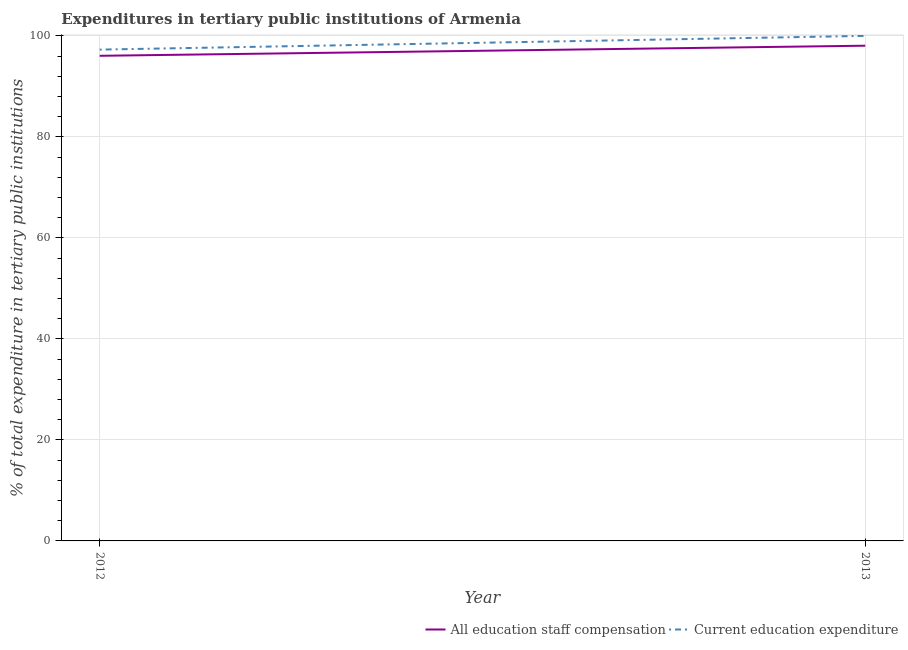What is the expenditure in staff compensation in 2013?
Keep it short and to the point. 98.05. Across all years, what is the maximum expenditure in staff compensation?
Your answer should be compact. 98.05. Across all years, what is the minimum expenditure in education?
Provide a succinct answer. 97.28. What is the total expenditure in staff compensation in the graph?
Offer a terse response. 194.1. What is the difference between the expenditure in education in 2012 and that in 2013?
Offer a very short reply. -2.72. What is the difference between the expenditure in education in 2013 and the expenditure in staff compensation in 2012?
Offer a very short reply. 3.95. What is the average expenditure in education per year?
Provide a succinct answer. 98.64. In the year 2012, what is the difference between the expenditure in education and expenditure in staff compensation?
Provide a short and direct response. 1.23. In how many years, is the expenditure in education greater than 12 %?
Give a very brief answer. 2. What is the ratio of the expenditure in staff compensation in 2012 to that in 2013?
Offer a very short reply. 0.98. In how many years, is the expenditure in staff compensation greater than the average expenditure in staff compensation taken over all years?
Give a very brief answer. 1. Is the expenditure in education strictly less than the expenditure in staff compensation over the years?
Your response must be concise. No. How many lines are there?
Give a very brief answer. 2. How many years are there in the graph?
Give a very brief answer. 2. Does the graph contain any zero values?
Offer a terse response. No. What is the title of the graph?
Ensure brevity in your answer.  Expenditures in tertiary public institutions of Armenia. What is the label or title of the X-axis?
Give a very brief answer. Year. What is the label or title of the Y-axis?
Offer a terse response. % of total expenditure in tertiary public institutions. What is the % of total expenditure in tertiary public institutions in All education staff compensation in 2012?
Make the answer very short. 96.05. What is the % of total expenditure in tertiary public institutions in Current education expenditure in 2012?
Provide a short and direct response. 97.28. What is the % of total expenditure in tertiary public institutions in All education staff compensation in 2013?
Ensure brevity in your answer.  98.05. What is the % of total expenditure in tertiary public institutions in Current education expenditure in 2013?
Your response must be concise. 100. Across all years, what is the maximum % of total expenditure in tertiary public institutions of All education staff compensation?
Ensure brevity in your answer.  98.05. Across all years, what is the maximum % of total expenditure in tertiary public institutions of Current education expenditure?
Your answer should be very brief. 100. Across all years, what is the minimum % of total expenditure in tertiary public institutions of All education staff compensation?
Keep it short and to the point. 96.05. Across all years, what is the minimum % of total expenditure in tertiary public institutions in Current education expenditure?
Ensure brevity in your answer.  97.28. What is the total % of total expenditure in tertiary public institutions of All education staff compensation in the graph?
Ensure brevity in your answer.  194.1. What is the total % of total expenditure in tertiary public institutions of Current education expenditure in the graph?
Ensure brevity in your answer.  197.28. What is the difference between the % of total expenditure in tertiary public institutions of All education staff compensation in 2012 and that in 2013?
Give a very brief answer. -2. What is the difference between the % of total expenditure in tertiary public institutions of Current education expenditure in 2012 and that in 2013?
Provide a succinct answer. -2.72. What is the difference between the % of total expenditure in tertiary public institutions of All education staff compensation in 2012 and the % of total expenditure in tertiary public institutions of Current education expenditure in 2013?
Make the answer very short. -3.95. What is the average % of total expenditure in tertiary public institutions in All education staff compensation per year?
Make the answer very short. 97.05. What is the average % of total expenditure in tertiary public institutions of Current education expenditure per year?
Offer a very short reply. 98.64. In the year 2012, what is the difference between the % of total expenditure in tertiary public institutions of All education staff compensation and % of total expenditure in tertiary public institutions of Current education expenditure?
Your answer should be very brief. -1.23. In the year 2013, what is the difference between the % of total expenditure in tertiary public institutions of All education staff compensation and % of total expenditure in tertiary public institutions of Current education expenditure?
Offer a very short reply. -1.95. What is the ratio of the % of total expenditure in tertiary public institutions of All education staff compensation in 2012 to that in 2013?
Keep it short and to the point. 0.98. What is the ratio of the % of total expenditure in tertiary public institutions of Current education expenditure in 2012 to that in 2013?
Make the answer very short. 0.97. What is the difference between the highest and the second highest % of total expenditure in tertiary public institutions of All education staff compensation?
Provide a succinct answer. 2. What is the difference between the highest and the second highest % of total expenditure in tertiary public institutions in Current education expenditure?
Make the answer very short. 2.72. What is the difference between the highest and the lowest % of total expenditure in tertiary public institutions of All education staff compensation?
Offer a very short reply. 2. What is the difference between the highest and the lowest % of total expenditure in tertiary public institutions of Current education expenditure?
Give a very brief answer. 2.72. 